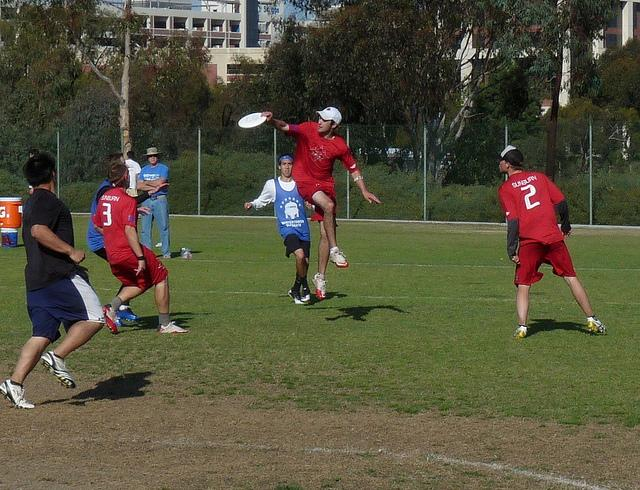What company has trademarked the popular name of this toy?

Choices:
A) fisher price
B) wham-o
C) hasbro
D) mattel wham-o 